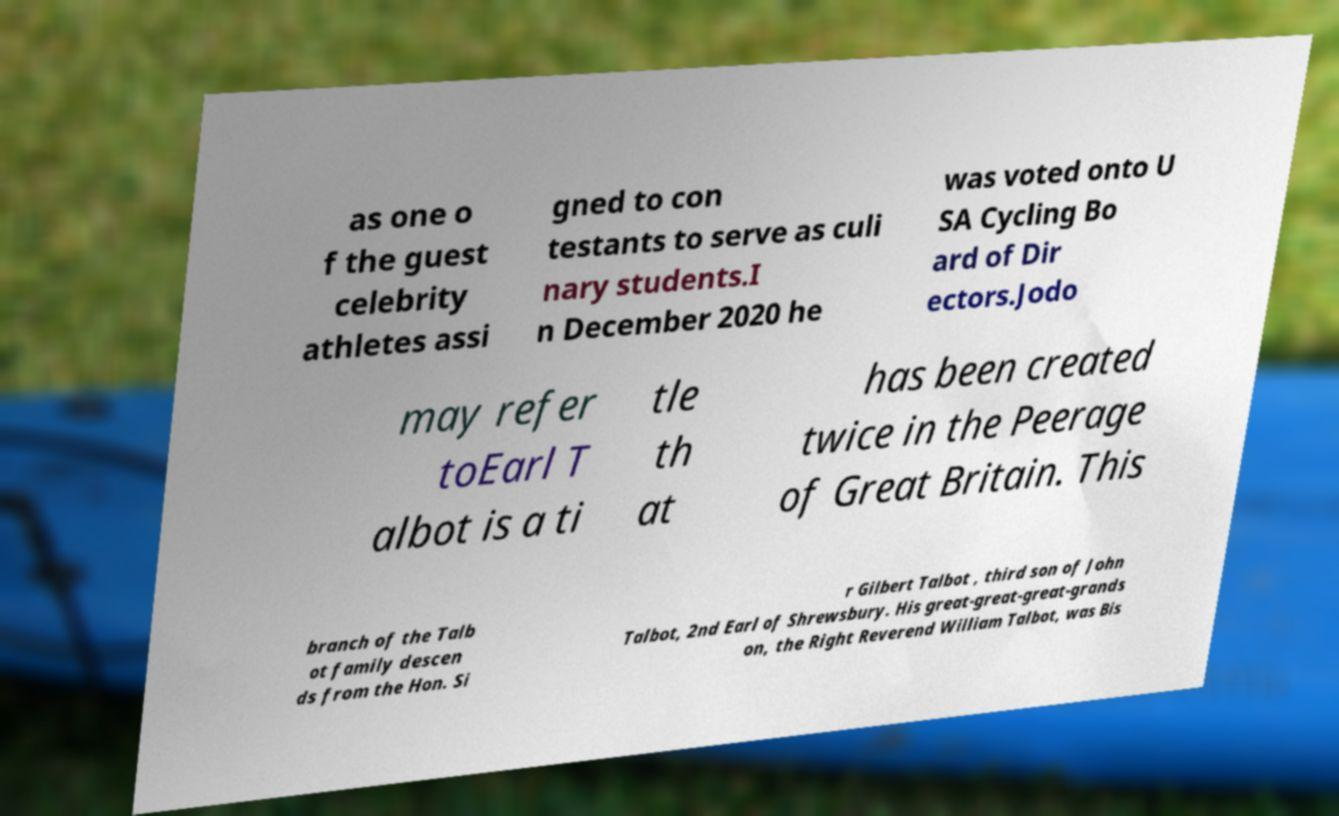There's text embedded in this image that I need extracted. Can you transcribe it verbatim? as one o f the guest celebrity athletes assi gned to con testants to serve as culi nary students.I n December 2020 he was voted onto U SA Cycling Bo ard of Dir ectors.Jodo may refer toEarl T albot is a ti tle th at has been created twice in the Peerage of Great Britain. This branch of the Talb ot family descen ds from the Hon. Si r Gilbert Talbot , third son of John Talbot, 2nd Earl of Shrewsbury. His great-great-great-grands on, the Right Reverend William Talbot, was Bis 